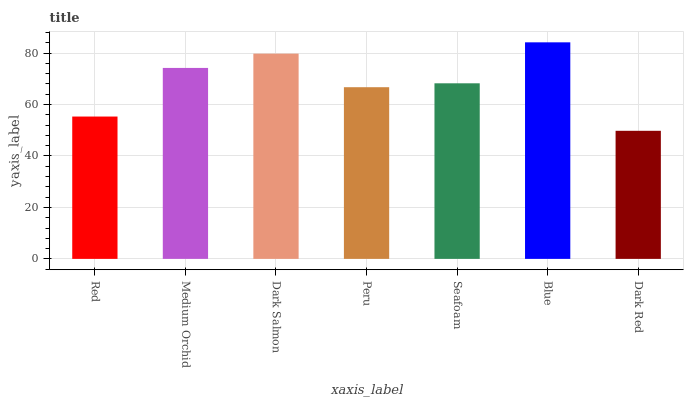Is Dark Red the minimum?
Answer yes or no. Yes. Is Blue the maximum?
Answer yes or no. Yes. Is Medium Orchid the minimum?
Answer yes or no. No. Is Medium Orchid the maximum?
Answer yes or no. No. Is Medium Orchid greater than Red?
Answer yes or no. Yes. Is Red less than Medium Orchid?
Answer yes or no. Yes. Is Red greater than Medium Orchid?
Answer yes or no. No. Is Medium Orchid less than Red?
Answer yes or no. No. Is Seafoam the high median?
Answer yes or no. Yes. Is Seafoam the low median?
Answer yes or no. Yes. Is Peru the high median?
Answer yes or no. No. Is Red the low median?
Answer yes or no. No. 